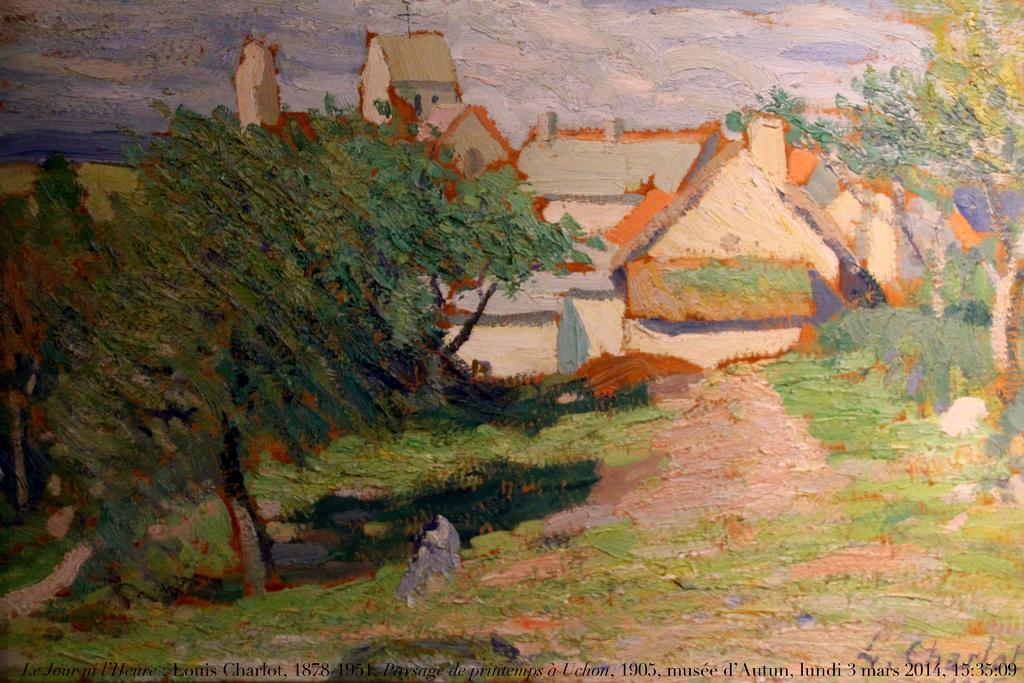How would you summarize this image in a sentence or two? This image consists of a paper with a painting on it. In this image there are a few houses and a few trees and plants on the ground. There is a sky with clouds. 